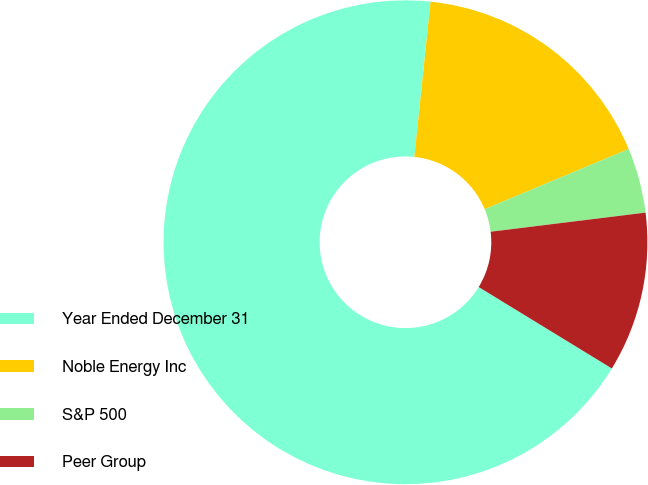<chart> <loc_0><loc_0><loc_500><loc_500><pie_chart><fcel>Year Ended December 31<fcel>Noble Energy Inc<fcel>S&P 500<fcel>Peer Group<nl><fcel>67.92%<fcel>17.05%<fcel>4.34%<fcel>10.69%<nl></chart> 